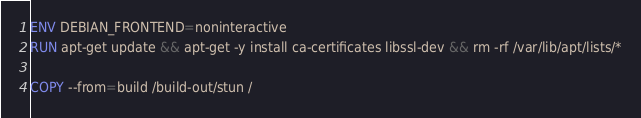<code> <loc_0><loc_0><loc_500><loc_500><_Dockerfile_>
ENV DEBIAN_FRONTEND=noninteractive
RUN apt-get update && apt-get -y install ca-certificates libssl-dev && rm -rf /var/lib/apt/lists/*

COPY --from=build /build-out/stun /</code> 